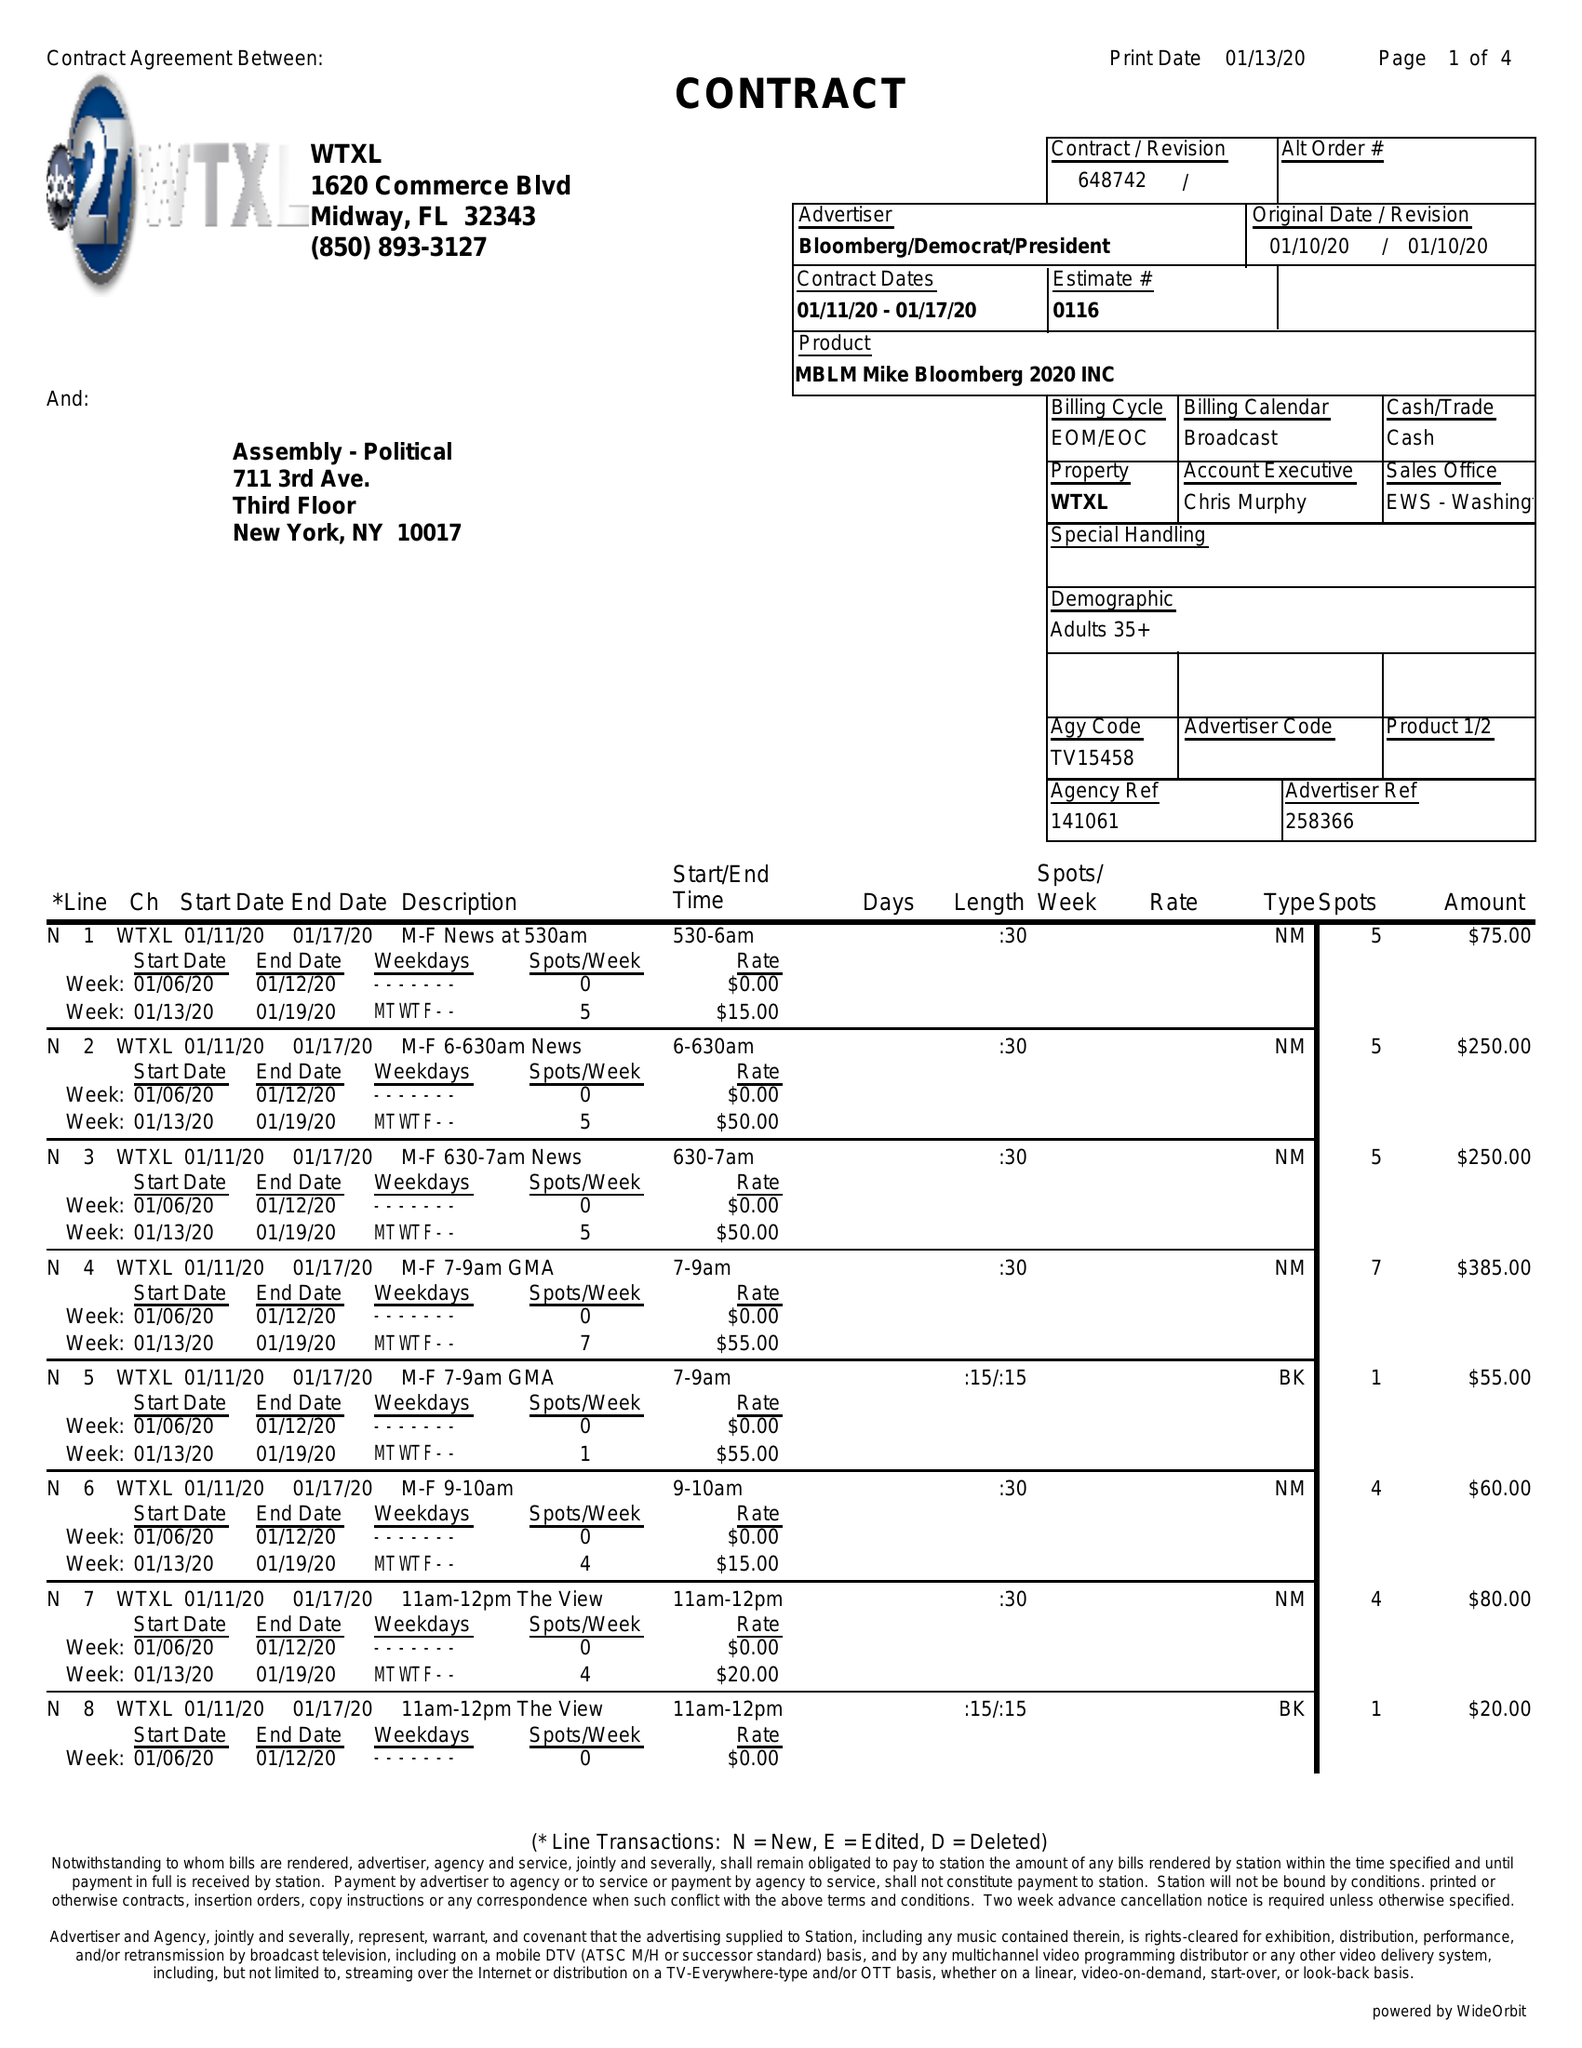What is the value for the contract_num?
Answer the question using a single word or phrase. 648742 